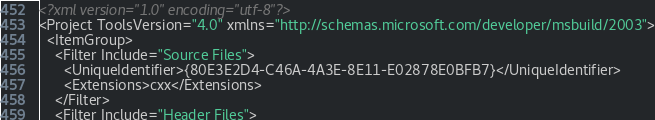Convert code to text. <code><loc_0><loc_0><loc_500><loc_500><_XML_><?xml version="1.0" encoding="utf-8"?>
<Project ToolsVersion="4.0" xmlns="http://schemas.microsoft.com/developer/msbuild/2003">
  <ItemGroup>
    <Filter Include="Source Files">
      <UniqueIdentifier>{80E3E2D4-C46A-4A3E-8E11-E02878E0BFB7}</UniqueIdentifier>
      <Extensions>cxx</Extensions>
    </Filter>
    <Filter Include="Header Files"></code> 